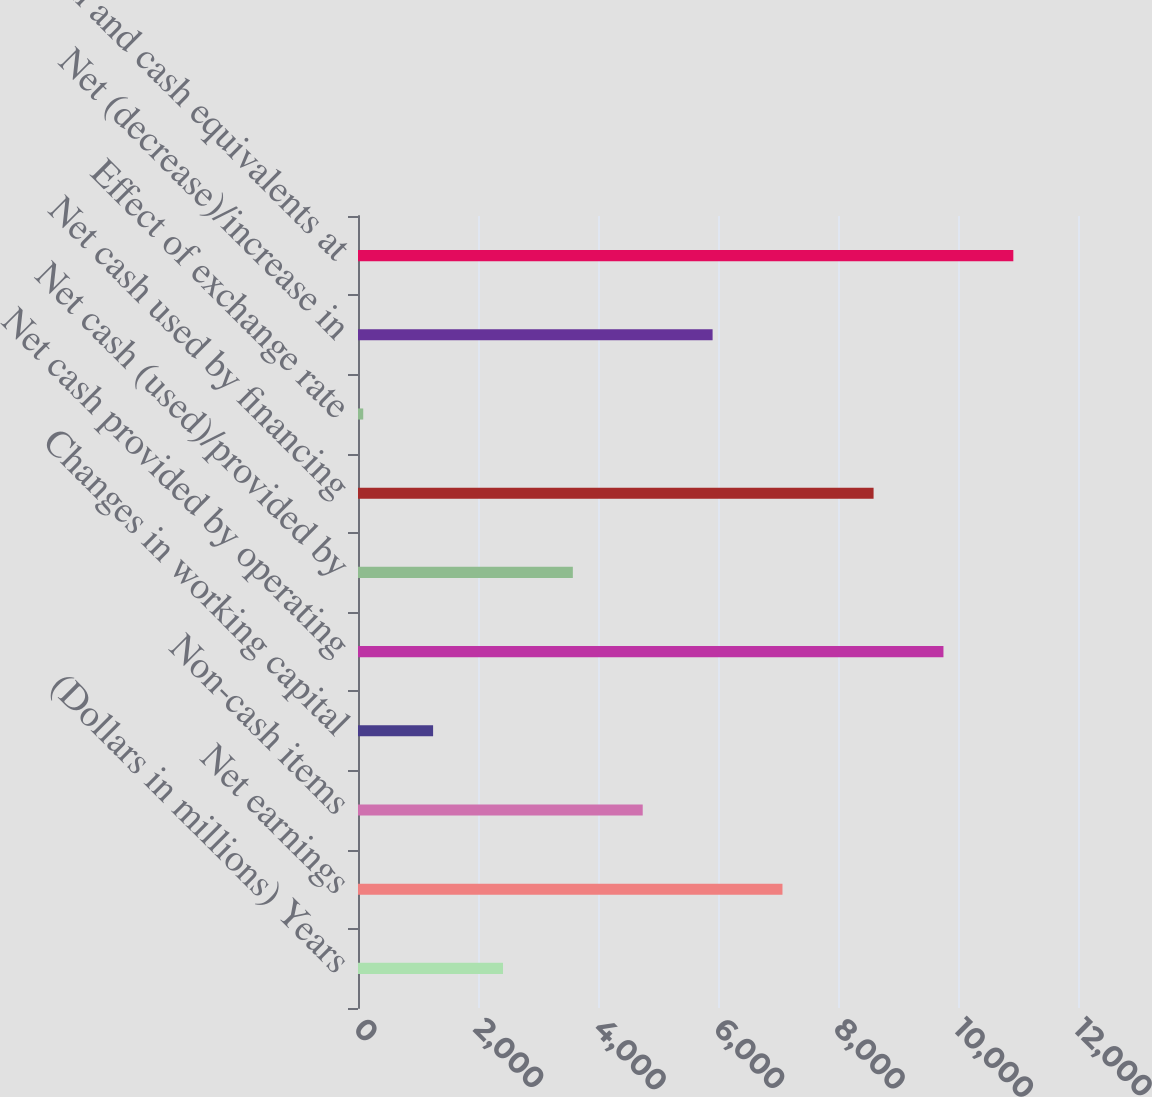Convert chart to OTSL. <chart><loc_0><loc_0><loc_500><loc_500><bar_chart><fcel>(Dollars in millions) Years<fcel>Net earnings<fcel>Non-cash items<fcel>Changes in working capital<fcel>Net cash provided by operating<fcel>Net cash (used)/provided by<fcel>Net cash used by financing<fcel>Effect of exchange rate<fcel>Net (decrease)/increase in<fcel>Cash and cash equivalents at<nl><fcel>2416.2<fcel>7074.6<fcel>4745.4<fcel>1251.6<fcel>9757.6<fcel>3580.8<fcel>8593<fcel>87<fcel>5910<fcel>10922.2<nl></chart> 